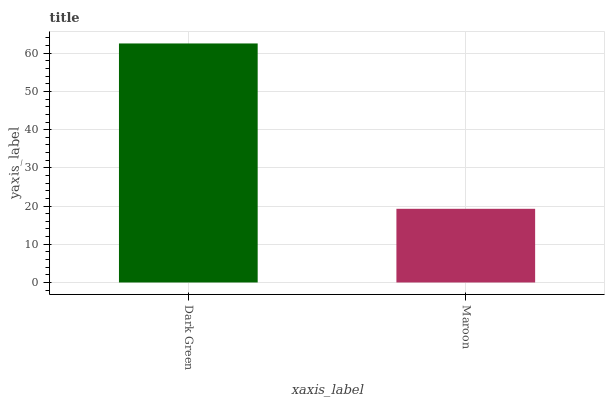Is Maroon the minimum?
Answer yes or no. Yes. Is Dark Green the maximum?
Answer yes or no. Yes. Is Maroon the maximum?
Answer yes or no. No. Is Dark Green greater than Maroon?
Answer yes or no. Yes. Is Maroon less than Dark Green?
Answer yes or no. Yes. Is Maroon greater than Dark Green?
Answer yes or no. No. Is Dark Green less than Maroon?
Answer yes or no. No. Is Dark Green the high median?
Answer yes or no. Yes. Is Maroon the low median?
Answer yes or no. Yes. Is Maroon the high median?
Answer yes or no. No. Is Dark Green the low median?
Answer yes or no. No. 